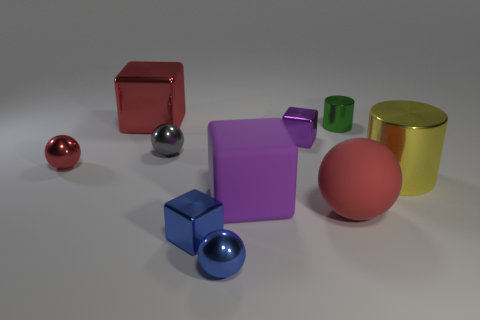What could be the purpose of assembling these various colored and shaped objects together? This assembly of objects may have been arranged to study or demonstrate differences in shape, color, and perhaps material properties. It's reminiscent of a visual composition you might find in an educational setting or as part of a design aesthetic test.  Could these objects represent something more abstract, such as concepts or emotions? Certainly, the variety of objects could symbolize a spectrum of concepts or emotions. For example, the solid square might denote stability, the sphere could suggest wholeness or unity, and the vibrant colors might evoke a range of feelings from energy (yellow) to tranquility (blue). 